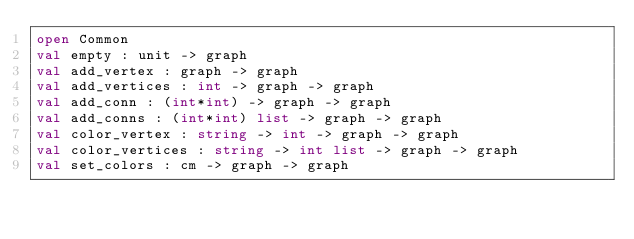Convert code to text. <code><loc_0><loc_0><loc_500><loc_500><_OCaml_>open Common
val empty : unit -> graph
val add_vertex : graph -> graph
val add_vertices : int -> graph -> graph
val add_conn : (int*int) -> graph -> graph
val add_conns : (int*int) list -> graph -> graph
val color_vertex : string -> int -> graph -> graph
val color_vertices : string -> int list -> graph -> graph
val set_colors : cm -> graph -> graph
</code> 